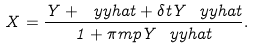<formula> <loc_0><loc_0><loc_500><loc_500>X = \frac { Y + \ y y h a t + \delta t Y \ y y h a t } { 1 + \pi m p Y \ y y h a t } .</formula> 